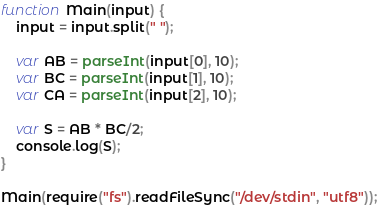<code> <loc_0><loc_0><loc_500><loc_500><_JavaScript_>function Main(input) {
    input = input.split(" ");

    var AB = parseInt(input[0], 10);
    var BC = parseInt(input[1], 10);
    var CA = parseInt(input[2], 10);
   
    var S = AB * BC/2;
    console.log(S);
}  

Main(require("fs").readFileSync("/dev/stdin", "utf8"));</code> 